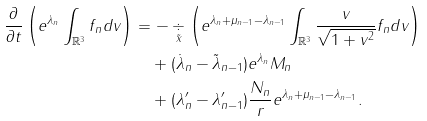Convert formula to latex. <formula><loc_0><loc_0><loc_500><loc_500>\frac { \partial } { \partial t } \left ( e ^ { \lambda _ { n } } \int _ { \mathbb { R } ^ { 3 } } f _ { n } d v \right ) & = - \underset { \tilde { x } } { \div } \left ( e ^ { \lambda _ { n } + \mu _ { n - 1 } - \lambda _ { n - 1 } } \int _ { \mathbb { R } ^ { 3 } } \frac { v } { \sqrt { 1 + v ^ { 2 } } } f _ { n } d v \right ) \\ & \quad + ( \dot { \lambda } _ { n } - \tilde { \lambda } _ { n - 1 } ) e ^ { \lambda _ { n } } M _ { n } \\ & \quad + ( \lambda _ { n } ^ { \prime } - \lambda _ { n - 1 } ^ { \prime } ) \frac { N _ { n } } { r } e ^ { \lambda _ { n } + \mu _ { n - 1 } - \lambda _ { n - 1 } } .</formula> 